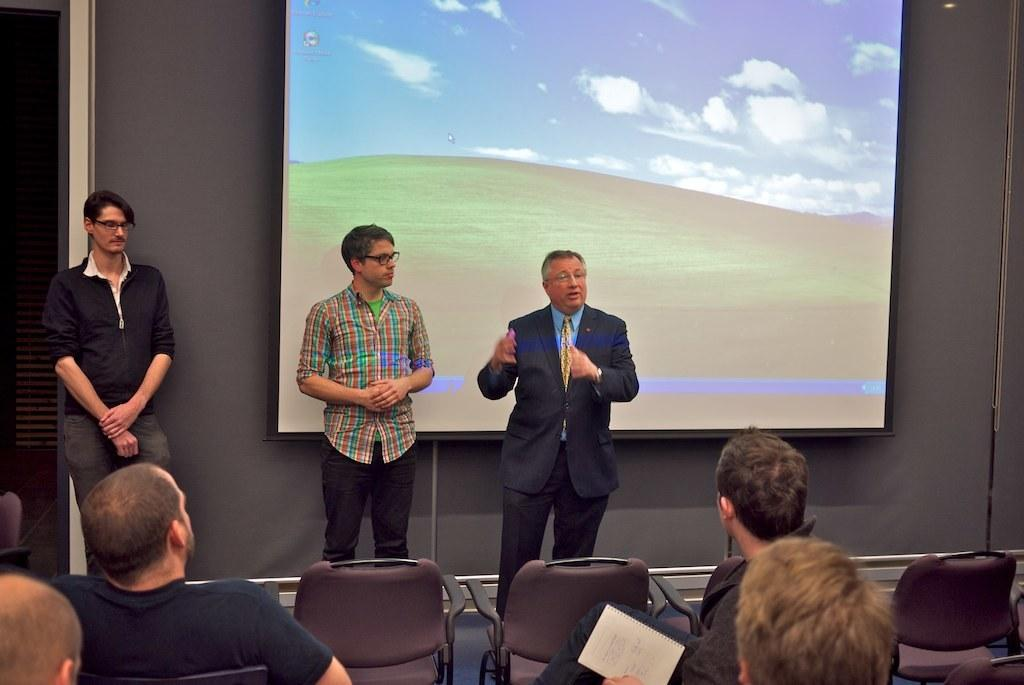What are the people in the image doing? There are people seated on chairs and people standing in front of the seated people in the image. What might be the purpose of the standing people? The standing people might be presenting or addressing the seated people. What is the main feature of the image related to visual display? There is a projector screen in the image. How many apples are on the projector screen in the image? There are no apples present on the projector screen in the image. What letter is being displayed on the projector screen in the image? There is no letter displayed on the projector screen in the image. 